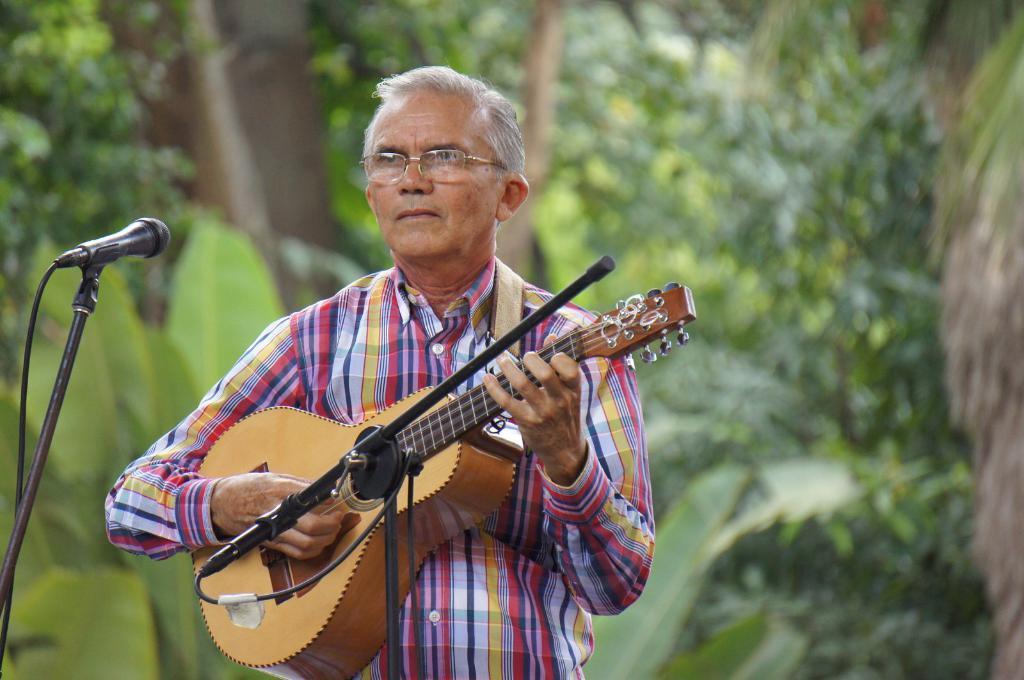In one or two sentences, can you explain what this image depicts? In this image a man is standing holding a guitar in his hand and playing the music. This image is taken in outdoors. In the left side of the image there is a mic. In the background there are many trees and plants. 